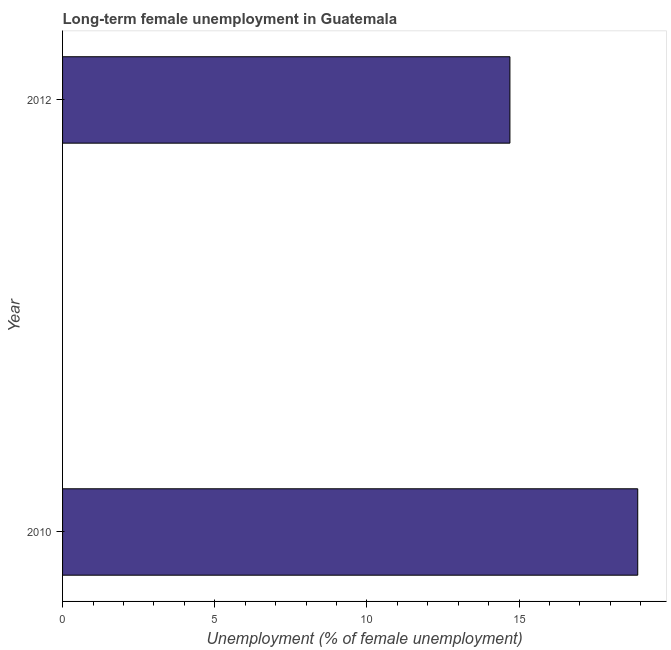Does the graph contain grids?
Offer a very short reply. No. What is the title of the graph?
Offer a very short reply. Long-term female unemployment in Guatemala. What is the label or title of the X-axis?
Provide a short and direct response. Unemployment (% of female unemployment). What is the label or title of the Y-axis?
Your answer should be very brief. Year. What is the long-term female unemployment in 2010?
Offer a terse response. 18.9. Across all years, what is the maximum long-term female unemployment?
Your answer should be compact. 18.9. Across all years, what is the minimum long-term female unemployment?
Your response must be concise. 14.7. In which year was the long-term female unemployment maximum?
Offer a terse response. 2010. In which year was the long-term female unemployment minimum?
Ensure brevity in your answer.  2012. What is the sum of the long-term female unemployment?
Provide a succinct answer. 33.6. What is the median long-term female unemployment?
Your answer should be very brief. 16.8. In how many years, is the long-term female unemployment greater than 17 %?
Your response must be concise. 1. What is the ratio of the long-term female unemployment in 2010 to that in 2012?
Your answer should be very brief. 1.29. In how many years, is the long-term female unemployment greater than the average long-term female unemployment taken over all years?
Your answer should be compact. 1. Are all the bars in the graph horizontal?
Provide a succinct answer. Yes. What is the difference between two consecutive major ticks on the X-axis?
Ensure brevity in your answer.  5. Are the values on the major ticks of X-axis written in scientific E-notation?
Your answer should be compact. No. What is the Unemployment (% of female unemployment) of 2010?
Your answer should be very brief. 18.9. What is the Unemployment (% of female unemployment) of 2012?
Offer a terse response. 14.7. What is the ratio of the Unemployment (% of female unemployment) in 2010 to that in 2012?
Provide a succinct answer. 1.29. 